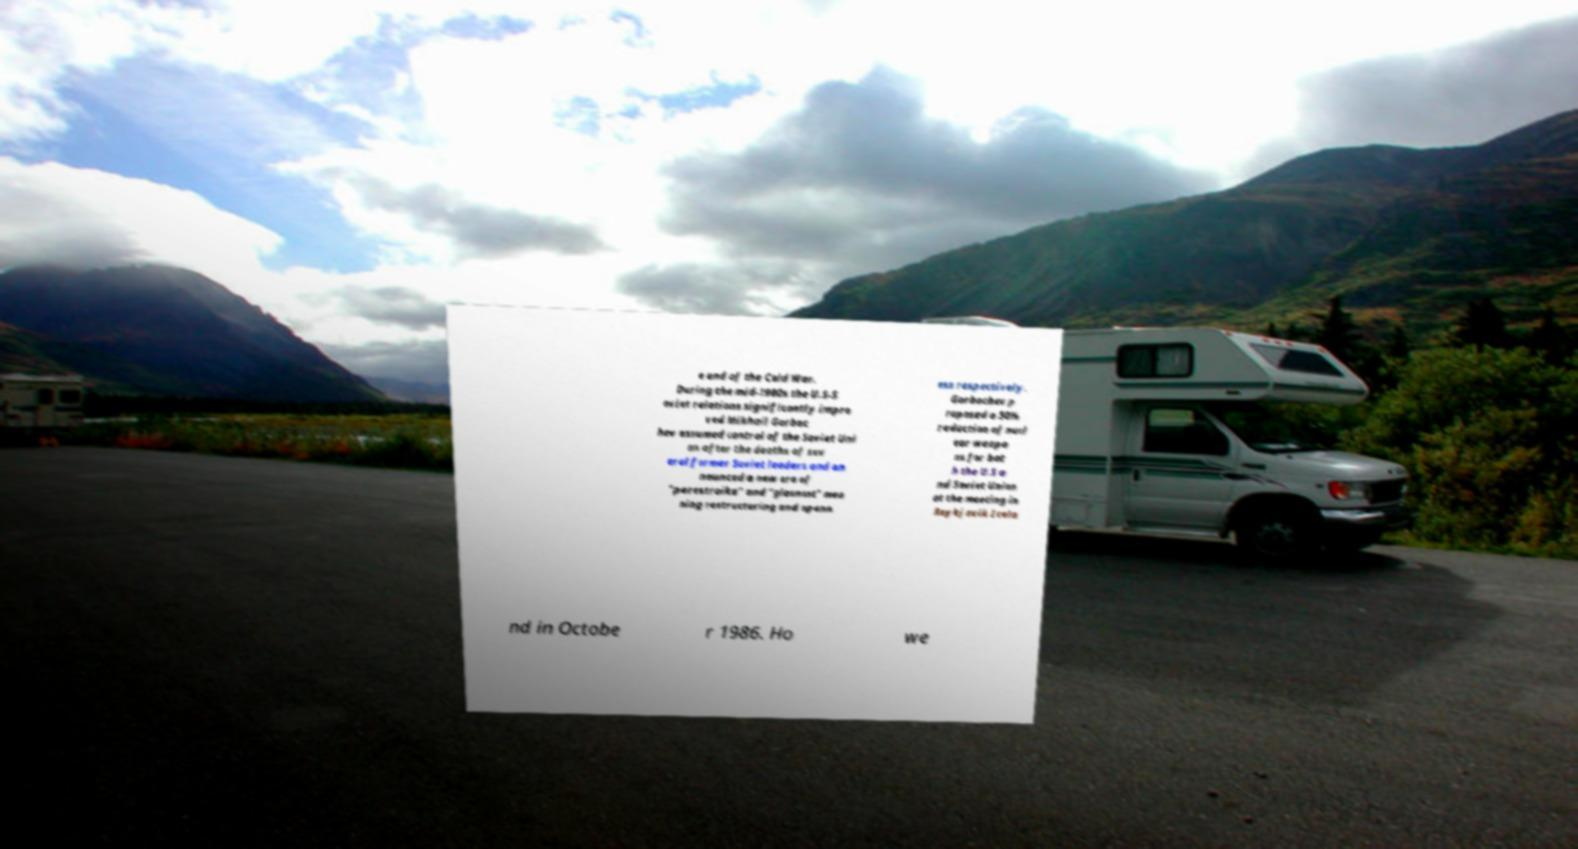Please identify and transcribe the text found in this image. e end of the Cold War. During the mid-1980s the U.S-S oviet relations significantly impro ved Mikhail Gorbac hev assumed control of the Soviet Uni on after the deaths of sev eral former Soviet leaders and an nounced a new era of "perestroika" and "glasnost" mea ning restructuring and openn ess respectively. Gorbachev p roposed a 50% reduction of nucl ear weapo ns for bot h the U.S a nd Soviet Union at the meeting in Reykjavik Icela nd in Octobe r 1986. Ho we 